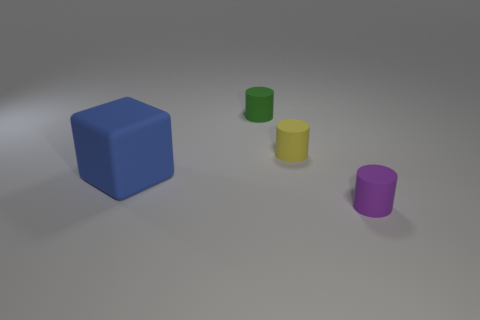The rubber thing that is to the left of the tiny green matte cylinder to the right of the big cube is what color?
Your answer should be compact. Blue. Is there a large purple shiny object?
Ensure brevity in your answer.  No. There is a object that is on the left side of the green object; what is its shape?
Provide a succinct answer. Cube. How many things are in front of the tiny yellow rubber cylinder and to the right of the big blue object?
Your response must be concise. 1. How many other things are the same size as the blue block?
Offer a terse response. 0. There is a thing in front of the big blue matte cube; does it have the same shape as the small yellow rubber object that is on the right side of the blue thing?
Your answer should be compact. Yes. How many objects are either small yellow objects or tiny cylinders that are on the left side of the small purple thing?
Give a very brief answer. 2. What is the thing that is on the left side of the small yellow object and behind the large blue matte block made of?
Your answer should be compact. Rubber. Are there any other things that are the same shape as the big matte object?
Keep it short and to the point. No. The cube that is made of the same material as the yellow object is what color?
Provide a succinct answer. Blue. 